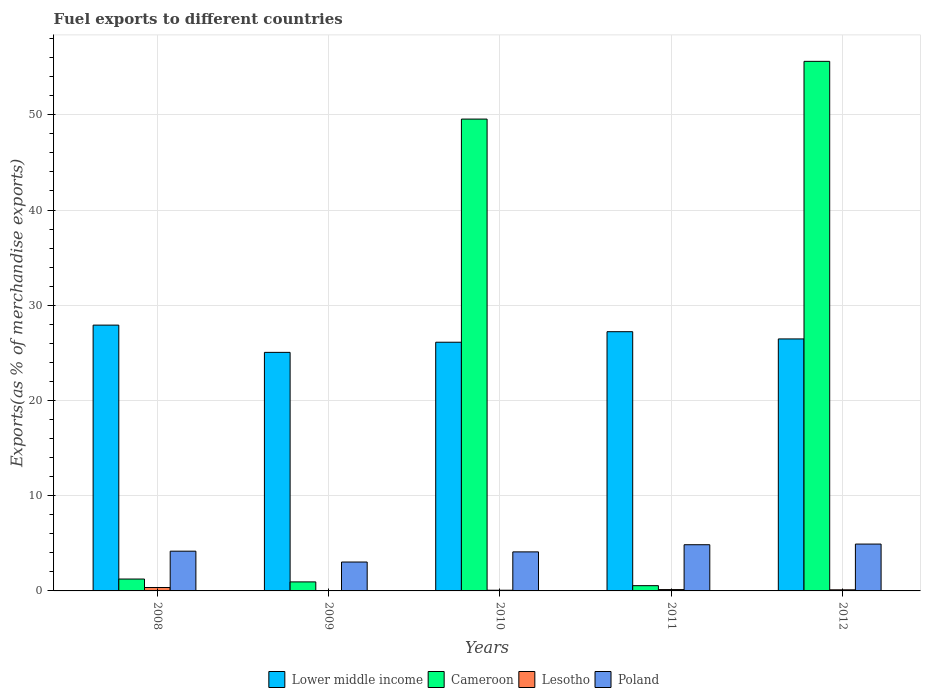How many different coloured bars are there?
Keep it short and to the point. 4. How many groups of bars are there?
Provide a short and direct response. 5. How many bars are there on the 1st tick from the left?
Provide a short and direct response. 4. How many bars are there on the 3rd tick from the right?
Give a very brief answer. 4. What is the label of the 2nd group of bars from the left?
Ensure brevity in your answer.  2009. What is the percentage of exports to different countries in Cameroon in 2012?
Give a very brief answer. 55.61. Across all years, what is the maximum percentage of exports to different countries in Cameroon?
Ensure brevity in your answer.  55.61. Across all years, what is the minimum percentage of exports to different countries in Poland?
Keep it short and to the point. 3.03. In which year was the percentage of exports to different countries in Lower middle income minimum?
Offer a very short reply. 2009. What is the total percentage of exports to different countries in Lesotho in the graph?
Provide a succinct answer. 0.7. What is the difference between the percentage of exports to different countries in Poland in 2011 and that in 2012?
Ensure brevity in your answer.  -0.07. What is the difference between the percentage of exports to different countries in Poland in 2010 and the percentage of exports to different countries in Cameroon in 2009?
Keep it short and to the point. 3.15. What is the average percentage of exports to different countries in Poland per year?
Offer a terse response. 4.22. In the year 2011, what is the difference between the percentage of exports to different countries in Lesotho and percentage of exports to different countries in Cameroon?
Keep it short and to the point. -0.41. What is the ratio of the percentage of exports to different countries in Lower middle income in 2009 to that in 2012?
Make the answer very short. 0.95. Is the difference between the percentage of exports to different countries in Lesotho in 2011 and 2012 greater than the difference between the percentage of exports to different countries in Cameroon in 2011 and 2012?
Give a very brief answer. Yes. What is the difference between the highest and the second highest percentage of exports to different countries in Cameroon?
Offer a terse response. 6.06. What is the difference between the highest and the lowest percentage of exports to different countries in Lower middle income?
Your answer should be very brief. 2.86. In how many years, is the percentage of exports to different countries in Lower middle income greater than the average percentage of exports to different countries in Lower middle income taken over all years?
Give a very brief answer. 2. What does the 3rd bar from the left in 2012 represents?
Offer a terse response. Lesotho. What does the 3rd bar from the right in 2009 represents?
Provide a short and direct response. Cameroon. Are all the bars in the graph horizontal?
Offer a very short reply. No. How many years are there in the graph?
Provide a short and direct response. 5. Are the values on the major ticks of Y-axis written in scientific E-notation?
Give a very brief answer. No. Does the graph contain any zero values?
Provide a succinct answer. No. How many legend labels are there?
Ensure brevity in your answer.  4. How are the legend labels stacked?
Make the answer very short. Horizontal. What is the title of the graph?
Offer a very short reply. Fuel exports to different countries. What is the label or title of the X-axis?
Offer a very short reply. Years. What is the label or title of the Y-axis?
Offer a very short reply. Exports(as % of merchandise exports). What is the Exports(as % of merchandise exports) of Lower middle income in 2008?
Your answer should be very brief. 27.91. What is the Exports(as % of merchandise exports) in Cameroon in 2008?
Offer a terse response. 1.25. What is the Exports(as % of merchandise exports) of Lesotho in 2008?
Provide a succinct answer. 0.36. What is the Exports(as % of merchandise exports) of Poland in 2008?
Provide a short and direct response. 4.17. What is the Exports(as % of merchandise exports) of Lower middle income in 2009?
Offer a very short reply. 25.05. What is the Exports(as % of merchandise exports) in Cameroon in 2009?
Give a very brief answer. 0.95. What is the Exports(as % of merchandise exports) in Lesotho in 2009?
Your response must be concise. 0.02. What is the Exports(as % of merchandise exports) of Poland in 2009?
Your answer should be very brief. 3.03. What is the Exports(as % of merchandise exports) in Lower middle income in 2010?
Provide a succinct answer. 26.12. What is the Exports(as % of merchandise exports) of Cameroon in 2010?
Offer a terse response. 49.55. What is the Exports(as % of merchandise exports) of Lesotho in 2010?
Your response must be concise. 0.07. What is the Exports(as % of merchandise exports) of Poland in 2010?
Your answer should be very brief. 4.1. What is the Exports(as % of merchandise exports) in Lower middle income in 2011?
Offer a very short reply. 27.22. What is the Exports(as % of merchandise exports) in Cameroon in 2011?
Ensure brevity in your answer.  0.55. What is the Exports(as % of merchandise exports) of Lesotho in 2011?
Give a very brief answer. 0.14. What is the Exports(as % of merchandise exports) in Poland in 2011?
Your response must be concise. 4.85. What is the Exports(as % of merchandise exports) of Lower middle income in 2012?
Your answer should be compact. 26.46. What is the Exports(as % of merchandise exports) in Cameroon in 2012?
Make the answer very short. 55.61. What is the Exports(as % of merchandise exports) of Lesotho in 2012?
Give a very brief answer. 0.12. What is the Exports(as % of merchandise exports) of Poland in 2012?
Offer a very short reply. 4.92. Across all years, what is the maximum Exports(as % of merchandise exports) in Lower middle income?
Your answer should be very brief. 27.91. Across all years, what is the maximum Exports(as % of merchandise exports) in Cameroon?
Ensure brevity in your answer.  55.61. Across all years, what is the maximum Exports(as % of merchandise exports) in Lesotho?
Ensure brevity in your answer.  0.36. Across all years, what is the maximum Exports(as % of merchandise exports) in Poland?
Your answer should be compact. 4.92. Across all years, what is the minimum Exports(as % of merchandise exports) in Lower middle income?
Give a very brief answer. 25.05. Across all years, what is the minimum Exports(as % of merchandise exports) in Cameroon?
Give a very brief answer. 0.55. Across all years, what is the minimum Exports(as % of merchandise exports) of Lesotho?
Provide a short and direct response. 0.02. Across all years, what is the minimum Exports(as % of merchandise exports) of Poland?
Provide a succinct answer. 3.03. What is the total Exports(as % of merchandise exports) of Lower middle income in the graph?
Give a very brief answer. 132.77. What is the total Exports(as % of merchandise exports) in Cameroon in the graph?
Your answer should be compact. 107.91. What is the total Exports(as % of merchandise exports) of Lesotho in the graph?
Give a very brief answer. 0.7. What is the total Exports(as % of merchandise exports) of Poland in the graph?
Provide a succinct answer. 21.08. What is the difference between the Exports(as % of merchandise exports) in Lower middle income in 2008 and that in 2009?
Provide a short and direct response. 2.86. What is the difference between the Exports(as % of merchandise exports) of Cameroon in 2008 and that in 2009?
Your answer should be compact. 0.3. What is the difference between the Exports(as % of merchandise exports) in Lesotho in 2008 and that in 2009?
Make the answer very short. 0.34. What is the difference between the Exports(as % of merchandise exports) in Poland in 2008 and that in 2009?
Provide a succinct answer. 1.14. What is the difference between the Exports(as % of merchandise exports) of Lower middle income in 2008 and that in 2010?
Offer a very short reply. 1.8. What is the difference between the Exports(as % of merchandise exports) of Cameroon in 2008 and that in 2010?
Offer a very short reply. -48.3. What is the difference between the Exports(as % of merchandise exports) in Lesotho in 2008 and that in 2010?
Ensure brevity in your answer.  0.29. What is the difference between the Exports(as % of merchandise exports) of Poland in 2008 and that in 2010?
Your response must be concise. 0.07. What is the difference between the Exports(as % of merchandise exports) of Lower middle income in 2008 and that in 2011?
Your response must be concise. 0.69. What is the difference between the Exports(as % of merchandise exports) in Cameroon in 2008 and that in 2011?
Your answer should be very brief. 0.69. What is the difference between the Exports(as % of merchandise exports) in Lesotho in 2008 and that in 2011?
Your response must be concise. 0.22. What is the difference between the Exports(as % of merchandise exports) in Poland in 2008 and that in 2011?
Offer a very short reply. -0.68. What is the difference between the Exports(as % of merchandise exports) in Lower middle income in 2008 and that in 2012?
Your answer should be compact. 1.45. What is the difference between the Exports(as % of merchandise exports) in Cameroon in 2008 and that in 2012?
Give a very brief answer. -54.36. What is the difference between the Exports(as % of merchandise exports) of Lesotho in 2008 and that in 2012?
Make the answer very short. 0.24. What is the difference between the Exports(as % of merchandise exports) of Poland in 2008 and that in 2012?
Your response must be concise. -0.75. What is the difference between the Exports(as % of merchandise exports) in Lower middle income in 2009 and that in 2010?
Provide a succinct answer. -1.07. What is the difference between the Exports(as % of merchandise exports) of Cameroon in 2009 and that in 2010?
Keep it short and to the point. -48.6. What is the difference between the Exports(as % of merchandise exports) in Lesotho in 2009 and that in 2010?
Offer a terse response. -0.06. What is the difference between the Exports(as % of merchandise exports) in Poland in 2009 and that in 2010?
Provide a succinct answer. -1.06. What is the difference between the Exports(as % of merchandise exports) in Lower middle income in 2009 and that in 2011?
Keep it short and to the point. -2.17. What is the difference between the Exports(as % of merchandise exports) in Cameroon in 2009 and that in 2011?
Make the answer very short. 0.4. What is the difference between the Exports(as % of merchandise exports) in Lesotho in 2009 and that in 2011?
Keep it short and to the point. -0.12. What is the difference between the Exports(as % of merchandise exports) of Poland in 2009 and that in 2011?
Your answer should be very brief. -1.82. What is the difference between the Exports(as % of merchandise exports) of Lower middle income in 2009 and that in 2012?
Keep it short and to the point. -1.41. What is the difference between the Exports(as % of merchandise exports) of Cameroon in 2009 and that in 2012?
Your answer should be compact. -54.66. What is the difference between the Exports(as % of merchandise exports) of Lesotho in 2009 and that in 2012?
Provide a succinct answer. -0.1. What is the difference between the Exports(as % of merchandise exports) of Poland in 2009 and that in 2012?
Give a very brief answer. -1.89. What is the difference between the Exports(as % of merchandise exports) of Lower middle income in 2010 and that in 2011?
Offer a very short reply. -1.1. What is the difference between the Exports(as % of merchandise exports) in Cameroon in 2010 and that in 2011?
Offer a terse response. 49. What is the difference between the Exports(as % of merchandise exports) of Lesotho in 2010 and that in 2011?
Provide a succinct answer. -0.07. What is the difference between the Exports(as % of merchandise exports) of Poland in 2010 and that in 2011?
Offer a terse response. -0.75. What is the difference between the Exports(as % of merchandise exports) of Lower middle income in 2010 and that in 2012?
Your answer should be compact. -0.35. What is the difference between the Exports(as % of merchandise exports) in Cameroon in 2010 and that in 2012?
Offer a terse response. -6.06. What is the difference between the Exports(as % of merchandise exports) in Lesotho in 2010 and that in 2012?
Offer a very short reply. -0.04. What is the difference between the Exports(as % of merchandise exports) of Poland in 2010 and that in 2012?
Make the answer very short. -0.82. What is the difference between the Exports(as % of merchandise exports) in Lower middle income in 2011 and that in 2012?
Provide a succinct answer. 0.76. What is the difference between the Exports(as % of merchandise exports) of Cameroon in 2011 and that in 2012?
Provide a short and direct response. -55.06. What is the difference between the Exports(as % of merchandise exports) in Lesotho in 2011 and that in 2012?
Provide a short and direct response. 0.02. What is the difference between the Exports(as % of merchandise exports) of Poland in 2011 and that in 2012?
Keep it short and to the point. -0.07. What is the difference between the Exports(as % of merchandise exports) of Lower middle income in 2008 and the Exports(as % of merchandise exports) of Cameroon in 2009?
Your answer should be very brief. 26.97. What is the difference between the Exports(as % of merchandise exports) of Lower middle income in 2008 and the Exports(as % of merchandise exports) of Lesotho in 2009?
Keep it short and to the point. 27.9. What is the difference between the Exports(as % of merchandise exports) of Lower middle income in 2008 and the Exports(as % of merchandise exports) of Poland in 2009?
Give a very brief answer. 24.88. What is the difference between the Exports(as % of merchandise exports) of Cameroon in 2008 and the Exports(as % of merchandise exports) of Lesotho in 2009?
Your answer should be compact. 1.23. What is the difference between the Exports(as % of merchandise exports) in Cameroon in 2008 and the Exports(as % of merchandise exports) in Poland in 2009?
Your response must be concise. -1.79. What is the difference between the Exports(as % of merchandise exports) in Lesotho in 2008 and the Exports(as % of merchandise exports) in Poland in 2009?
Provide a succinct answer. -2.68. What is the difference between the Exports(as % of merchandise exports) of Lower middle income in 2008 and the Exports(as % of merchandise exports) of Cameroon in 2010?
Give a very brief answer. -21.63. What is the difference between the Exports(as % of merchandise exports) of Lower middle income in 2008 and the Exports(as % of merchandise exports) of Lesotho in 2010?
Your answer should be very brief. 27.84. What is the difference between the Exports(as % of merchandise exports) in Lower middle income in 2008 and the Exports(as % of merchandise exports) in Poland in 2010?
Provide a short and direct response. 23.81. What is the difference between the Exports(as % of merchandise exports) of Cameroon in 2008 and the Exports(as % of merchandise exports) of Lesotho in 2010?
Provide a short and direct response. 1.17. What is the difference between the Exports(as % of merchandise exports) of Cameroon in 2008 and the Exports(as % of merchandise exports) of Poland in 2010?
Keep it short and to the point. -2.85. What is the difference between the Exports(as % of merchandise exports) in Lesotho in 2008 and the Exports(as % of merchandise exports) in Poland in 2010?
Offer a very short reply. -3.74. What is the difference between the Exports(as % of merchandise exports) in Lower middle income in 2008 and the Exports(as % of merchandise exports) in Cameroon in 2011?
Keep it short and to the point. 27.36. What is the difference between the Exports(as % of merchandise exports) in Lower middle income in 2008 and the Exports(as % of merchandise exports) in Lesotho in 2011?
Offer a very short reply. 27.77. What is the difference between the Exports(as % of merchandise exports) of Lower middle income in 2008 and the Exports(as % of merchandise exports) of Poland in 2011?
Your answer should be compact. 23.06. What is the difference between the Exports(as % of merchandise exports) in Cameroon in 2008 and the Exports(as % of merchandise exports) in Lesotho in 2011?
Your answer should be compact. 1.11. What is the difference between the Exports(as % of merchandise exports) of Cameroon in 2008 and the Exports(as % of merchandise exports) of Poland in 2011?
Offer a very short reply. -3.6. What is the difference between the Exports(as % of merchandise exports) of Lesotho in 2008 and the Exports(as % of merchandise exports) of Poland in 2011?
Make the answer very short. -4.49. What is the difference between the Exports(as % of merchandise exports) of Lower middle income in 2008 and the Exports(as % of merchandise exports) of Cameroon in 2012?
Provide a short and direct response. -27.7. What is the difference between the Exports(as % of merchandise exports) of Lower middle income in 2008 and the Exports(as % of merchandise exports) of Lesotho in 2012?
Provide a succinct answer. 27.8. What is the difference between the Exports(as % of merchandise exports) of Lower middle income in 2008 and the Exports(as % of merchandise exports) of Poland in 2012?
Offer a terse response. 22.99. What is the difference between the Exports(as % of merchandise exports) of Cameroon in 2008 and the Exports(as % of merchandise exports) of Lesotho in 2012?
Your answer should be very brief. 1.13. What is the difference between the Exports(as % of merchandise exports) of Cameroon in 2008 and the Exports(as % of merchandise exports) of Poland in 2012?
Ensure brevity in your answer.  -3.67. What is the difference between the Exports(as % of merchandise exports) of Lesotho in 2008 and the Exports(as % of merchandise exports) of Poland in 2012?
Your answer should be very brief. -4.56. What is the difference between the Exports(as % of merchandise exports) of Lower middle income in 2009 and the Exports(as % of merchandise exports) of Cameroon in 2010?
Offer a terse response. -24.5. What is the difference between the Exports(as % of merchandise exports) in Lower middle income in 2009 and the Exports(as % of merchandise exports) in Lesotho in 2010?
Ensure brevity in your answer.  24.98. What is the difference between the Exports(as % of merchandise exports) in Lower middle income in 2009 and the Exports(as % of merchandise exports) in Poland in 2010?
Keep it short and to the point. 20.95. What is the difference between the Exports(as % of merchandise exports) in Cameroon in 2009 and the Exports(as % of merchandise exports) in Lesotho in 2010?
Your answer should be very brief. 0.88. What is the difference between the Exports(as % of merchandise exports) in Cameroon in 2009 and the Exports(as % of merchandise exports) in Poland in 2010?
Provide a short and direct response. -3.15. What is the difference between the Exports(as % of merchandise exports) of Lesotho in 2009 and the Exports(as % of merchandise exports) of Poland in 2010?
Provide a short and direct response. -4.08. What is the difference between the Exports(as % of merchandise exports) in Lower middle income in 2009 and the Exports(as % of merchandise exports) in Cameroon in 2011?
Make the answer very short. 24.5. What is the difference between the Exports(as % of merchandise exports) in Lower middle income in 2009 and the Exports(as % of merchandise exports) in Lesotho in 2011?
Your response must be concise. 24.91. What is the difference between the Exports(as % of merchandise exports) of Lower middle income in 2009 and the Exports(as % of merchandise exports) of Poland in 2011?
Offer a terse response. 20.2. What is the difference between the Exports(as % of merchandise exports) in Cameroon in 2009 and the Exports(as % of merchandise exports) in Lesotho in 2011?
Your answer should be very brief. 0.81. What is the difference between the Exports(as % of merchandise exports) of Cameroon in 2009 and the Exports(as % of merchandise exports) of Poland in 2011?
Your answer should be very brief. -3.9. What is the difference between the Exports(as % of merchandise exports) in Lesotho in 2009 and the Exports(as % of merchandise exports) in Poland in 2011?
Provide a short and direct response. -4.84. What is the difference between the Exports(as % of merchandise exports) of Lower middle income in 2009 and the Exports(as % of merchandise exports) of Cameroon in 2012?
Offer a terse response. -30.56. What is the difference between the Exports(as % of merchandise exports) in Lower middle income in 2009 and the Exports(as % of merchandise exports) in Lesotho in 2012?
Your answer should be very brief. 24.93. What is the difference between the Exports(as % of merchandise exports) in Lower middle income in 2009 and the Exports(as % of merchandise exports) in Poland in 2012?
Offer a terse response. 20.13. What is the difference between the Exports(as % of merchandise exports) of Cameroon in 2009 and the Exports(as % of merchandise exports) of Lesotho in 2012?
Provide a short and direct response. 0.83. What is the difference between the Exports(as % of merchandise exports) in Cameroon in 2009 and the Exports(as % of merchandise exports) in Poland in 2012?
Your answer should be compact. -3.97. What is the difference between the Exports(as % of merchandise exports) in Lesotho in 2009 and the Exports(as % of merchandise exports) in Poland in 2012?
Your answer should be very brief. -4.9. What is the difference between the Exports(as % of merchandise exports) of Lower middle income in 2010 and the Exports(as % of merchandise exports) of Cameroon in 2011?
Offer a very short reply. 25.56. What is the difference between the Exports(as % of merchandise exports) in Lower middle income in 2010 and the Exports(as % of merchandise exports) in Lesotho in 2011?
Give a very brief answer. 25.98. What is the difference between the Exports(as % of merchandise exports) of Lower middle income in 2010 and the Exports(as % of merchandise exports) of Poland in 2011?
Your answer should be very brief. 21.27. What is the difference between the Exports(as % of merchandise exports) in Cameroon in 2010 and the Exports(as % of merchandise exports) in Lesotho in 2011?
Your answer should be compact. 49.41. What is the difference between the Exports(as % of merchandise exports) in Cameroon in 2010 and the Exports(as % of merchandise exports) in Poland in 2011?
Your answer should be very brief. 44.7. What is the difference between the Exports(as % of merchandise exports) of Lesotho in 2010 and the Exports(as % of merchandise exports) of Poland in 2011?
Provide a succinct answer. -4.78. What is the difference between the Exports(as % of merchandise exports) of Lower middle income in 2010 and the Exports(as % of merchandise exports) of Cameroon in 2012?
Ensure brevity in your answer.  -29.49. What is the difference between the Exports(as % of merchandise exports) of Lower middle income in 2010 and the Exports(as % of merchandise exports) of Lesotho in 2012?
Your response must be concise. 26. What is the difference between the Exports(as % of merchandise exports) in Lower middle income in 2010 and the Exports(as % of merchandise exports) in Poland in 2012?
Provide a short and direct response. 21.2. What is the difference between the Exports(as % of merchandise exports) in Cameroon in 2010 and the Exports(as % of merchandise exports) in Lesotho in 2012?
Give a very brief answer. 49.43. What is the difference between the Exports(as % of merchandise exports) of Cameroon in 2010 and the Exports(as % of merchandise exports) of Poland in 2012?
Ensure brevity in your answer.  44.63. What is the difference between the Exports(as % of merchandise exports) in Lesotho in 2010 and the Exports(as % of merchandise exports) in Poland in 2012?
Give a very brief answer. -4.85. What is the difference between the Exports(as % of merchandise exports) in Lower middle income in 2011 and the Exports(as % of merchandise exports) in Cameroon in 2012?
Make the answer very short. -28.39. What is the difference between the Exports(as % of merchandise exports) in Lower middle income in 2011 and the Exports(as % of merchandise exports) in Lesotho in 2012?
Provide a succinct answer. 27.11. What is the difference between the Exports(as % of merchandise exports) of Lower middle income in 2011 and the Exports(as % of merchandise exports) of Poland in 2012?
Provide a short and direct response. 22.3. What is the difference between the Exports(as % of merchandise exports) in Cameroon in 2011 and the Exports(as % of merchandise exports) in Lesotho in 2012?
Your response must be concise. 0.44. What is the difference between the Exports(as % of merchandise exports) in Cameroon in 2011 and the Exports(as % of merchandise exports) in Poland in 2012?
Offer a very short reply. -4.37. What is the difference between the Exports(as % of merchandise exports) in Lesotho in 2011 and the Exports(as % of merchandise exports) in Poland in 2012?
Offer a terse response. -4.78. What is the average Exports(as % of merchandise exports) of Lower middle income per year?
Your response must be concise. 26.55. What is the average Exports(as % of merchandise exports) of Cameroon per year?
Your answer should be very brief. 21.58. What is the average Exports(as % of merchandise exports) of Lesotho per year?
Give a very brief answer. 0.14. What is the average Exports(as % of merchandise exports) of Poland per year?
Ensure brevity in your answer.  4.22. In the year 2008, what is the difference between the Exports(as % of merchandise exports) of Lower middle income and Exports(as % of merchandise exports) of Cameroon?
Keep it short and to the point. 26.67. In the year 2008, what is the difference between the Exports(as % of merchandise exports) of Lower middle income and Exports(as % of merchandise exports) of Lesotho?
Your answer should be very brief. 27.55. In the year 2008, what is the difference between the Exports(as % of merchandise exports) of Lower middle income and Exports(as % of merchandise exports) of Poland?
Ensure brevity in your answer.  23.74. In the year 2008, what is the difference between the Exports(as % of merchandise exports) of Cameroon and Exports(as % of merchandise exports) of Lesotho?
Ensure brevity in your answer.  0.89. In the year 2008, what is the difference between the Exports(as % of merchandise exports) in Cameroon and Exports(as % of merchandise exports) in Poland?
Give a very brief answer. -2.93. In the year 2008, what is the difference between the Exports(as % of merchandise exports) of Lesotho and Exports(as % of merchandise exports) of Poland?
Your response must be concise. -3.81. In the year 2009, what is the difference between the Exports(as % of merchandise exports) of Lower middle income and Exports(as % of merchandise exports) of Cameroon?
Give a very brief answer. 24.1. In the year 2009, what is the difference between the Exports(as % of merchandise exports) in Lower middle income and Exports(as % of merchandise exports) in Lesotho?
Ensure brevity in your answer.  25.04. In the year 2009, what is the difference between the Exports(as % of merchandise exports) of Lower middle income and Exports(as % of merchandise exports) of Poland?
Give a very brief answer. 22.02. In the year 2009, what is the difference between the Exports(as % of merchandise exports) in Cameroon and Exports(as % of merchandise exports) in Lesotho?
Keep it short and to the point. 0.93. In the year 2009, what is the difference between the Exports(as % of merchandise exports) in Cameroon and Exports(as % of merchandise exports) in Poland?
Offer a terse response. -2.09. In the year 2009, what is the difference between the Exports(as % of merchandise exports) in Lesotho and Exports(as % of merchandise exports) in Poland?
Your response must be concise. -3.02. In the year 2010, what is the difference between the Exports(as % of merchandise exports) in Lower middle income and Exports(as % of merchandise exports) in Cameroon?
Give a very brief answer. -23.43. In the year 2010, what is the difference between the Exports(as % of merchandise exports) of Lower middle income and Exports(as % of merchandise exports) of Lesotho?
Your answer should be very brief. 26.04. In the year 2010, what is the difference between the Exports(as % of merchandise exports) of Lower middle income and Exports(as % of merchandise exports) of Poland?
Keep it short and to the point. 22.02. In the year 2010, what is the difference between the Exports(as % of merchandise exports) in Cameroon and Exports(as % of merchandise exports) in Lesotho?
Offer a very short reply. 49.48. In the year 2010, what is the difference between the Exports(as % of merchandise exports) of Cameroon and Exports(as % of merchandise exports) of Poland?
Your response must be concise. 45.45. In the year 2010, what is the difference between the Exports(as % of merchandise exports) in Lesotho and Exports(as % of merchandise exports) in Poland?
Offer a very short reply. -4.03. In the year 2011, what is the difference between the Exports(as % of merchandise exports) in Lower middle income and Exports(as % of merchandise exports) in Cameroon?
Your answer should be compact. 26.67. In the year 2011, what is the difference between the Exports(as % of merchandise exports) in Lower middle income and Exports(as % of merchandise exports) in Lesotho?
Give a very brief answer. 27.08. In the year 2011, what is the difference between the Exports(as % of merchandise exports) of Lower middle income and Exports(as % of merchandise exports) of Poland?
Offer a terse response. 22.37. In the year 2011, what is the difference between the Exports(as % of merchandise exports) in Cameroon and Exports(as % of merchandise exports) in Lesotho?
Your answer should be compact. 0.41. In the year 2011, what is the difference between the Exports(as % of merchandise exports) of Cameroon and Exports(as % of merchandise exports) of Poland?
Ensure brevity in your answer.  -4.3. In the year 2011, what is the difference between the Exports(as % of merchandise exports) of Lesotho and Exports(as % of merchandise exports) of Poland?
Offer a very short reply. -4.71. In the year 2012, what is the difference between the Exports(as % of merchandise exports) of Lower middle income and Exports(as % of merchandise exports) of Cameroon?
Offer a terse response. -29.15. In the year 2012, what is the difference between the Exports(as % of merchandise exports) of Lower middle income and Exports(as % of merchandise exports) of Lesotho?
Provide a short and direct response. 26.35. In the year 2012, what is the difference between the Exports(as % of merchandise exports) of Lower middle income and Exports(as % of merchandise exports) of Poland?
Your answer should be very brief. 21.54. In the year 2012, what is the difference between the Exports(as % of merchandise exports) in Cameroon and Exports(as % of merchandise exports) in Lesotho?
Your answer should be very brief. 55.5. In the year 2012, what is the difference between the Exports(as % of merchandise exports) in Cameroon and Exports(as % of merchandise exports) in Poland?
Give a very brief answer. 50.69. In the year 2012, what is the difference between the Exports(as % of merchandise exports) of Lesotho and Exports(as % of merchandise exports) of Poland?
Make the answer very short. -4.8. What is the ratio of the Exports(as % of merchandise exports) of Lower middle income in 2008 to that in 2009?
Offer a terse response. 1.11. What is the ratio of the Exports(as % of merchandise exports) in Cameroon in 2008 to that in 2009?
Provide a short and direct response. 1.32. What is the ratio of the Exports(as % of merchandise exports) of Lesotho in 2008 to that in 2009?
Your answer should be very brief. 22.53. What is the ratio of the Exports(as % of merchandise exports) of Poland in 2008 to that in 2009?
Provide a succinct answer. 1.38. What is the ratio of the Exports(as % of merchandise exports) of Lower middle income in 2008 to that in 2010?
Provide a succinct answer. 1.07. What is the ratio of the Exports(as % of merchandise exports) of Cameroon in 2008 to that in 2010?
Offer a very short reply. 0.03. What is the ratio of the Exports(as % of merchandise exports) in Lesotho in 2008 to that in 2010?
Ensure brevity in your answer.  4.95. What is the ratio of the Exports(as % of merchandise exports) of Poland in 2008 to that in 2010?
Make the answer very short. 1.02. What is the ratio of the Exports(as % of merchandise exports) of Lower middle income in 2008 to that in 2011?
Offer a terse response. 1.03. What is the ratio of the Exports(as % of merchandise exports) in Cameroon in 2008 to that in 2011?
Your response must be concise. 2.26. What is the ratio of the Exports(as % of merchandise exports) of Lesotho in 2008 to that in 2011?
Offer a terse response. 2.56. What is the ratio of the Exports(as % of merchandise exports) in Poland in 2008 to that in 2011?
Provide a short and direct response. 0.86. What is the ratio of the Exports(as % of merchandise exports) of Lower middle income in 2008 to that in 2012?
Your answer should be very brief. 1.05. What is the ratio of the Exports(as % of merchandise exports) of Cameroon in 2008 to that in 2012?
Your response must be concise. 0.02. What is the ratio of the Exports(as % of merchandise exports) in Lesotho in 2008 to that in 2012?
Ensure brevity in your answer.  3.09. What is the ratio of the Exports(as % of merchandise exports) of Poland in 2008 to that in 2012?
Offer a terse response. 0.85. What is the ratio of the Exports(as % of merchandise exports) in Lower middle income in 2009 to that in 2010?
Offer a terse response. 0.96. What is the ratio of the Exports(as % of merchandise exports) in Cameroon in 2009 to that in 2010?
Ensure brevity in your answer.  0.02. What is the ratio of the Exports(as % of merchandise exports) of Lesotho in 2009 to that in 2010?
Keep it short and to the point. 0.22. What is the ratio of the Exports(as % of merchandise exports) in Poland in 2009 to that in 2010?
Give a very brief answer. 0.74. What is the ratio of the Exports(as % of merchandise exports) of Lower middle income in 2009 to that in 2011?
Ensure brevity in your answer.  0.92. What is the ratio of the Exports(as % of merchandise exports) of Cameroon in 2009 to that in 2011?
Give a very brief answer. 1.72. What is the ratio of the Exports(as % of merchandise exports) in Lesotho in 2009 to that in 2011?
Offer a very short reply. 0.11. What is the ratio of the Exports(as % of merchandise exports) in Poland in 2009 to that in 2011?
Keep it short and to the point. 0.63. What is the ratio of the Exports(as % of merchandise exports) of Lower middle income in 2009 to that in 2012?
Provide a short and direct response. 0.95. What is the ratio of the Exports(as % of merchandise exports) of Cameroon in 2009 to that in 2012?
Your answer should be compact. 0.02. What is the ratio of the Exports(as % of merchandise exports) of Lesotho in 2009 to that in 2012?
Your answer should be compact. 0.14. What is the ratio of the Exports(as % of merchandise exports) in Poland in 2009 to that in 2012?
Make the answer very short. 0.62. What is the ratio of the Exports(as % of merchandise exports) in Lower middle income in 2010 to that in 2011?
Offer a terse response. 0.96. What is the ratio of the Exports(as % of merchandise exports) of Cameroon in 2010 to that in 2011?
Provide a short and direct response. 89.72. What is the ratio of the Exports(as % of merchandise exports) of Lesotho in 2010 to that in 2011?
Your answer should be very brief. 0.52. What is the ratio of the Exports(as % of merchandise exports) of Poland in 2010 to that in 2011?
Offer a very short reply. 0.84. What is the ratio of the Exports(as % of merchandise exports) in Lower middle income in 2010 to that in 2012?
Give a very brief answer. 0.99. What is the ratio of the Exports(as % of merchandise exports) in Cameroon in 2010 to that in 2012?
Make the answer very short. 0.89. What is the ratio of the Exports(as % of merchandise exports) in Lesotho in 2010 to that in 2012?
Your answer should be compact. 0.62. What is the ratio of the Exports(as % of merchandise exports) of Poland in 2010 to that in 2012?
Your response must be concise. 0.83. What is the ratio of the Exports(as % of merchandise exports) in Lower middle income in 2011 to that in 2012?
Your answer should be compact. 1.03. What is the ratio of the Exports(as % of merchandise exports) of Cameroon in 2011 to that in 2012?
Your answer should be compact. 0.01. What is the ratio of the Exports(as % of merchandise exports) of Lesotho in 2011 to that in 2012?
Offer a very short reply. 1.21. What is the ratio of the Exports(as % of merchandise exports) in Poland in 2011 to that in 2012?
Ensure brevity in your answer.  0.99. What is the difference between the highest and the second highest Exports(as % of merchandise exports) in Lower middle income?
Make the answer very short. 0.69. What is the difference between the highest and the second highest Exports(as % of merchandise exports) in Cameroon?
Provide a succinct answer. 6.06. What is the difference between the highest and the second highest Exports(as % of merchandise exports) in Lesotho?
Offer a terse response. 0.22. What is the difference between the highest and the second highest Exports(as % of merchandise exports) of Poland?
Offer a very short reply. 0.07. What is the difference between the highest and the lowest Exports(as % of merchandise exports) in Lower middle income?
Offer a terse response. 2.86. What is the difference between the highest and the lowest Exports(as % of merchandise exports) of Cameroon?
Offer a very short reply. 55.06. What is the difference between the highest and the lowest Exports(as % of merchandise exports) in Lesotho?
Your answer should be compact. 0.34. What is the difference between the highest and the lowest Exports(as % of merchandise exports) of Poland?
Make the answer very short. 1.89. 